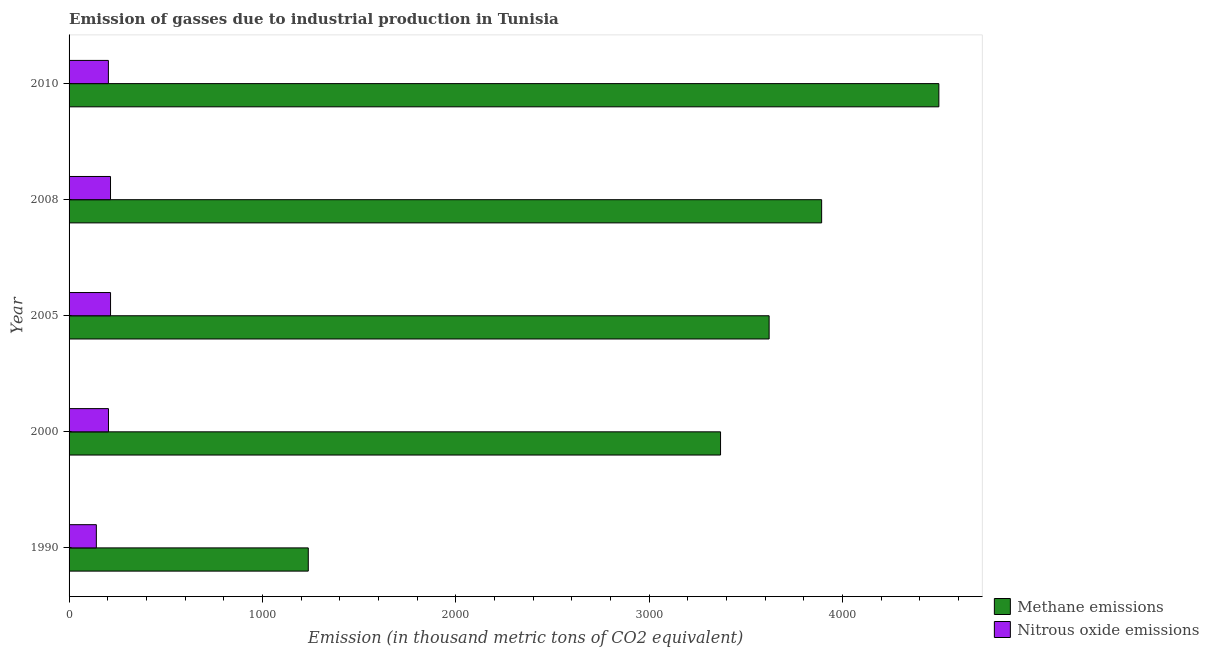How many different coloured bars are there?
Your response must be concise. 2. Are the number of bars on each tick of the Y-axis equal?
Your answer should be very brief. Yes. How many bars are there on the 4th tick from the top?
Offer a very short reply. 2. What is the label of the 3rd group of bars from the top?
Give a very brief answer. 2005. In how many cases, is the number of bars for a given year not equal to the number of legend labels?
Keep it short and to the point. 0. What is the amount of nitrous oxide emissions in 2010?
Make the answer very short. 203.3. Across all years, what is the maximum amount of methane emissions?
Offer a very short reply. 4497.8. Across all years, what is the minimum amount of nitrous oxide emissions?
Keep it short and to the point. 141. In which year was the amount of nitrous oxide emissions maximum?
Your answer should be compact. 2005. What is the total amount of methane emissions in the graph?
Ensure brevity in your answer.  1.66e+04. What is the difference between the amount of nitrous oxide emissions in 1990 and that in 2010?
Make the answer very short. -62.3. What is the difference between the amount of methane emissions in 2008 and the amount of nitrous oxide emissions in 1990?
Your answer should be compact. 3750.6. What is the average amount of methane emissions per year?
Keep it short and to the point. 3323.08. In the year 2000, what is the difference between the amount of methane emissions and amount of nitrous oxide emissions?
Your answer should be compact. 3165.2. In how many years, is the amount of methane emissions greater than 200 thousand metric tons?
Your answer should be very brief. 5. Is the amount of nitrous oxide emissions in 2000 less than that in 2010?
Your response must be concise. No. What is the difference between the highest and the lowest amount of methane emissions?
Provide a succinct answer. 3260.8. What does the 2nd bar from the top in 1990 represents?
Your response must be concise. Methane emissions. What does the 2nd bar from the bottom in 2008 represents?
Give a very brief answer. Nitrous oxide emissions. Are all the bars in the graph horizontal?
Your response must be concise. Yes. What is the difference between two consecutive major ticks on the X-axis?
Offer a very short reply. 1000. Are the values on the major ticks of X-axis written in scientific E-notation?
Ensure brevity in your answer.  No. Does the graph contain any zero values?
Your answer should be compact. No. Where does the legend appear in the graph?
Keep it short and to the point. Bottom right. How are the legend labels stacked?
Provide a short and direct response. Vertical. What is the title of the graph?
Your response must be concise. Emission of gasses due to industrial production in Tunisia. Does "Residents" appear as one of the legend labels in the graph?
Your answer should be very brief. No. What is the label or title of the X-axis?
Offer a very short reply. Emission (in thousand metric tons of CO2 equivalent). What is the Emission (in thousand metric tons of CO2 equivalent) of Methane emissions in 1990?
Offer a very short reply. 1237. What is the Emission (in thousand metric tons of CO2 equivalent) in Nitrous oxide emissions in 1990?
Offer a terse response. 141. What is the Emission (in thousand metric tons of CO2 equivalent) of Methane emissions in 2000?
Give a very brief answer. 3368.9. What is the Emission (in thousand metric tons of CO2 equivalent) in Nitrous oxide emissions in 2000?
Ensure brevity in your answer.  203.7. What is the Emission (in thousand metric tons of CO2 equivalent) in Methane emissions in 2005?
Provide a succinct answer. 3620.1. What is the Emission (in thousand metric tons of CO2 equivalent) of Nitrous oxide emissions in 2005?
Offer a very short reply. 214.5. What is the Emission (in thousand metric tons of CO2 equivalent) of Methane emissions in 2008?
Offer a terse response. 3891.6. What is the Emission (in thousand metric tons of CO2 equivalent) of Nitrous oxide emissions in 2008?
Give a very brief answer. 214.3. What is the Emission (in thousand metric tons of CO2 equivalent) in Methane emissions in 2010?
Give a very brief answer. 4497.8. What is the Emission (in thousand metric tons of CO2 equivalent) in Nitrous oxide emissions in 2010?
Your answer should be compact. 203.3. Across all years, what is the maximum Emission (in thousand metric tons of CO2 equivalent) in Methane emissions?
Your answer should be compact. 4497.8. Across all years, what is the maximum Emission (in thousand metric tons of CO2 equivalent) of Nitrous oxide emissions?
Offer a very short reply. 214.5. Across all years, what is the minimum Emission (in thousand metric tons of CO2 equivalent) of Methane emissions?
Ensure brevity in your answer.  1237. Across all years, what is the minimum Emission (in thousand metric tons of CO2 equivalent) in Nitrous oxide emissions?
Offer a terse response. 141. What is the total Emission (in thousand metric tons of CO2 equivalent) in Methane emissions in the graph?
Ensure brevity in your answer.  1.66e+04. What is the total Emission (in thousand metric tons of CO2 equivalent) in Nitrous oxide emissions in the graph?
Give a very brief answer. 976.8. What is the difference between the Emission (in thousand metric tons of CO2 equivalent) in Methane emissions in 1990 and that in 2000?
Provide a succinct answer. -2131.9. What is the difference between the Emission (in thousand metric tons of CO2 equivalent) of Nitrous oxide emissions in 1990 and that in 2000?
Offer a very short reply. -62.7. What is the difference between the Emission (in thousand metric tons of CO2 equivalent) in Methane emissions in 1990 and that in 2005?
Provide a short and direct response. -2383.1. What is the difference between the Emission (in thousand metric tons of CO2 equivalent) of Nitrous oxide emissions in 1990 and that in 2005?
Provide a succinct answer. -73.5. What is the difference between the Emission (in thousand metric tons of CO2 equivalent) in Methane emissions in 1990 and that in 2008?
Keep it short and to the point. -2654.6. What is the difference between the Emission (in thousand metric tons of CO2 equivalent) of Nitrous oxide emissions in 1990 and that in 2008?
Your response must be concise. -73.3. What is the difference between the Emission (in thousand metric tons of CO2 equivalent) in Methane emissions in 1990 and that in 2010?
Your response must be concise. -3260.8. What is the difference between the Emission (in thousand metric tons of CO2 equivalent) of Nitrous oxide emissions in 1990 and that in 2010?
Offer a very short reply. -62.3. What is the difference between the Emission (in thousand metric tons of CO2 equivalent) of Methane emissions in 2000 and that in 2005?
Provide a succinct answer. -251.2. What is the difference between the Emission (in thousand metric tons of CO2 equivalent) of Methane emissions in 2000 and that in 2008?
Ensure brevity in your answer.  -522.7. What is the difference between the Emission (in thousand metric tons of CO2 equivalent) in Methane emissions in 2000 and that in 2010?
Give a very brief answer. -1128.9. What is the difference between the Emission (in thousand metric tons of CO2 equivalent) in Methane emissions in 2005 and that in 2008?
Your response must be concise. -271.5. What is the difference between the Emission (in thousand metric tons of CO2 equivalent) of Methane emissions in 2005 and that in 2010?
Give a very brief answer. -877.7. What is the difference between the Emission (in thousand metric tons of CO2 equivalent) of Nitrous oxide emissions in 2005 and that in 2010?
Make the answer very short. 11.2. What is the difference between the Emission (in thousand metric tons of CO2 equivalent) in Methane emissions in 2008 and that in 2010?
Provide a succinct answer. -606.2. What is the difference between the Emission (in thousand metric tons of CO2 equivalent) of Methane emissions in 1990 and the Emission (in thousand metric tons of CO2 equivalent) of Nitrous oxide emissions in 2000?
Keep it short and to the point. 1033.3. What is the difference between the Emission (in thousand metric tons of CO2 equivalent) of Methane emissions in 1990 and the Emission (in thousand metric tons of CO2 equivalent) of Nitrous oxide emissions in 2005?
Make the answer very short. 1022.5. What is the difference between the Emission (in thousand metric tons of CO2 equivalent) of Methane emissions in 1990 and the Emission (in thousand metric tons of CO2 equivalent) of Nitrous oxide emissions in 2008?
Your response must be concise. 1022.7. What is the difference between the Emission (in thousand metric tons of CO2 equivalent) in Methane emissions in 1990 and the Emission (in thousand metric tons of CO2 equivalent) in Nitrous oxide emissions in 2010?
Offer a very short reply. 1033.7. What is the difference between the Emission (in thousand metric tons of CO2 equivalent) in Methane emissions in 2000 and the Emission (in thousand metric tons of CO2 equivalent) in Nitrous oxide emissions in 2005?
Provide a succinct answer. 3154.4. What is the difference between the Emission (in thousand metric tons of CO2 equivalent) of Methane emissions in 2000 and the Emission (in thousand metric tons of CO2 equivalent) of Nitrous oxide emissions in 2008?
Ensure brevity in your answer.  3154.6. What is the difference between the Emission (in thousand metric tons of CO2 equivalent) of Methane emissions in 2000 and the Emission (in thousand metric tons of CO2 equivalent) of Nitrous oxide emissions in 2010?
Make the answer very short. 3165.6. What is the difference between the Emission (in thousand metric tons of CO2 equivalent) of Methane emissions in 2005 and the Emission (in thousand metric tons of CO2 equivalent) of Nitrous oxide emissions in 2008?
Make the answer very short. 3405.8. What is the difference between the Emission (in thousand metric tons of CO2 equivalent) in Methane emissions in 2005 and the Emission (in thousand metric tons of CO2 equivalent) in Nitrous oxide emissions in 2010?
Your answer should be compact. 3416.8. What is the difference between the Emission (in thousand metric tons of CO2 equivalent) in Methane emissions in 2008 and the Emission (in thousand metric tons of CO2 equivalent) in Nitrous oxide emissions in 2010?
Give a very brief answer. 3688.3. What is the average Emission (in thousand metric tons of CO2 equivalent) of Methane emissions per year?
Your response must be concise. 3323.08. What is the average Emission (in thousand metric tons of CO2 equivalent) in Nitrous oxide emissions per year?
Keep it short and to the point. 195.36. In the year 1990, what is the difference between the Emission (in thousand metric tons of CO2 equivalent) of Methane emissions and Emission (in thousand metric tons of CO2 equivalent) of Nitrous oxide emissions?
Ensure brevity in your answer.  1096. In the year 2000, what is the difference between the Emission (in thousand metric tons of CO2 equivalent) of Methane emissions and Emission (in thousand metric tons of CO2 equivalent) of Nitrous oxide emissions?
Your answer should be very brief. 3165.2. In the year 2005, what is the difference between the Emission (in thousand metric tons of CO2 equivalent) of Methane emissions and Emission (in thousand metric tons of CO2 equivalent) of Nitrous oxide emissions?
Your answer should be compact. 3405.6. In the year 2008, what is the difference between the Emission (in thousand metric tons of CO2 equivalent) in Methane emissions and Emission (in thousand metric tons of CO2 equivalent) in Nitrous oxide emissions?
Your answer should be very brief. 3677.3. In the year 2010, what is the difference between the Emission (in thousand metric tons of CO2 equivalent) in Methane emissions and Emission (in thousand metric tons of CO2 equivalent) in Nitrous oxide emissions?
Your answer should be compact. 4294.5. What is the ratio of the Emission (in thousand metric tons of CO2 equivalent) in Methane emissions in 1990 to that in 2000?
Offer a terse response. 0.37. What is the ratio of the Emission (in thousand metric tons of CO2 equivalent) of Nitrous oxide emissions in 1990 to that in 2000?
Make the answer very short. 0.69. What is the ratio of the Emission (in thousand metric tons of CO2 equivalent) in Methane emissions in 1990 to that in 2005?
Offer a terse response. 0.34. What is the ratio of the Emission (in thousand metric tons of CO2 equivalent) in Nitrous oxide emissions in 1990 to that in 2005?
Give a very brief answer. 0.66. What is the ratio of the Emission (in thousand metric tons of CO2 equivalent) in Methane emissions in 1990 to that in 2008?
Provide a succinct answer. 0.32. What is the ratio of the Emission (in thousand metric tons of CO2 equivalent) of Nitrous oxide emissions in 1990 to that in 2008?
Offer a terse response. 0.66. What is the ratio of the Emission (in thousand metric tons of CO2 equivalent) in Methane emissions in 1990 to that in 2010?
Ensure brevity in your answer.  0.28. What is the ratio of the Emission (in thousand metric tons of CO2 equivalent) of Nitrous oxide emissions in 1990 to that in 2010?
Your answer should be compact. 0.69. What is the ratio of the Emission (in thousand metric tons of CO2 equivalent) of Methane emissions in 2000 to that in 2005?
Ensure brevity in your answer.  0.93. What is the ratio of the Emission (in thousand metric tons of CO2 equivalent) in Nitrous oxide emissions in 2000 to that in 2005?
Provide a short and direct response. 0.95. What is the ratio of the Emission (in thousand metric tons of CO2 equivalent) in Methane emissions in 2000 to that in 2008?
Provide a succinct answer. 0.87. What is the ratio of the Emission (in thousand metric tons of CO2 equivalent) of Nitrous oxide emissions in 2000 to that in 2008?
Keep it short and to the point. 0.95. What is the ratio of the Emission (in thousand metric tons of CO2 equivalent) in Methane emissions in 2000 to that in 2010?
Your answer should be compact. 0.75. What is the ratio of the Emission (in thousand metric tons of CO2 equivalent) of Methane emissions in 2005 to that in 2008?
Your response must be concise. 0.93. What is the ratio of the Emission (in thousand metric tons of CO2 equivalent) of Nitrous oxide emissions in 2005 to that in 2008?
Give a very brief answer. 1. What is the ratio of the Emission (in thousand metric tons of CO2 equivalent) of Methane emissions in 2005 to that in 2010?
Give a very brief answer. 0.8. What is the ratio of the Emission (in thousand metric tons of CO2 equivalent) in Nitrous oxide emissions in 2005 to that in 2010?
Offer a terse response. 1.06. What is the ratio of the Emission (in thousand metric tons of CO2 equivalent) in Methane emissions in 2008 to that in 2010?
Your answer should be compact. 0.87. What is the ratio of the Emission (in thousand metric tons of CO2 equivalent) in Nitrous oxide emissions in 2008 to that in 2010?
Keep it short and to the point. 1.05. What is the difference between the highest and the second highest Emission (in thousand metric tons of CO2 equivalent) of Methane emissions?
Provide a short and direct response. 606.2. What is the difference between the highest and the lowest Emission (in thousand metric tons of CO2 equivalent) of Methane emissions?
Give a very brief answer. 3260.8. What is the difference between the highest and the lowest Emission (in thousand metric tons of CO2 equivalent) of Nitrous oxide emissions?
Your response must be concise. 73.5. 